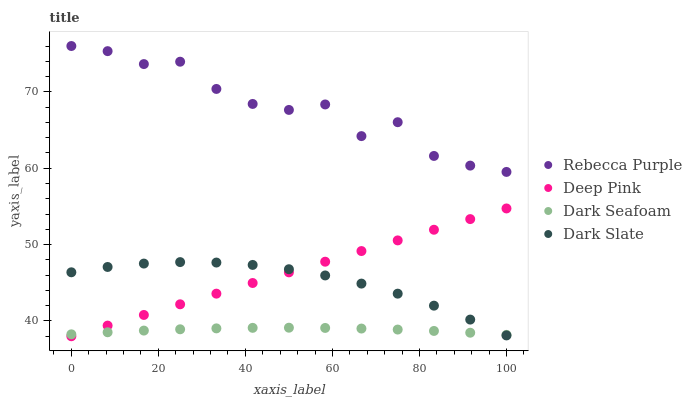Does Dark Seafoam have the minimum area under the curve?
Answer yes or no. Yes. Does Rebecca Purple have the maximum area under the curve?
Answer yes or no. Yes. Does Deep Pink have the minimum area under the curve?
Answer yes or no. No. Does Deep Pink have the maximum area under the curve?
Answer yes or no. No. Is Deep Pink the smoothest?
Answer yes or no. Yes. Is Rebecca Purple the roughest?
Answer yes or no. Yes. Is Dark Seafoam the smoothest?
Answer yes or no. No. Is Dark Seafoam the roughest?
Answer yes or no. No. Does Deep Pink have the lowest value?
Answer yes or no. Yes. Does Dark Seafoam have the lowest value?
Answer yes or no. No. Does Rebecca Purple have the highest value?
Answer yes or no. Yes. Does Deep Pink have the highest value?
Answer yes or no. No. Is Dark Slate less than Rebecca Purple?
Answer yes or no. Yes. Is Rebecca Purple greater than Deep Pink?
Answer yes or no. Yes. Does Dark Slate intersect Deep Pink?
Answer yes or no. Yes. Is Dark Slate less than Deep Pink?
Answer yes or no. No. Is Dark Slate greater than Deep Pink?
Answer yes or no. No. Does Dark Slate intersect Rebecca Purple?
Answer yes or no. No. 